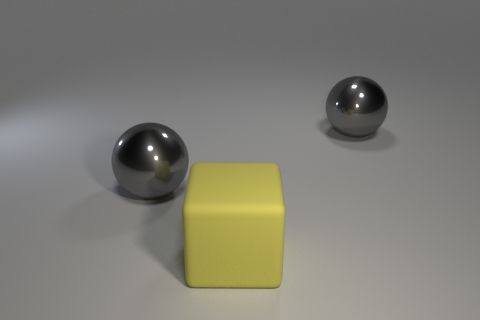Are there an equal number of rubber objects that are right of the large matte object and large green things?
Provide a succinct answer. Yes. The yellow matte cube is what size?
Ensure brevity in your answer.  Large. What number of blocks are left of the shiny thing that is to the right of the large matte block?
Offer a very short reply. 1. Are there any large metal balls that are on the left side of the large thing in front of the gray metallic thing that is left of the yellow cube?
Ensure brevity in your answer.  Yes. What number of balls are either large yellow objects or gray metal objects?
Provide a short and direct response. 2. What size is the gray sphere that is on the left side of the gray shiny thing behind the object that is on the left side of the matte cube?
Your answer should be very brief. Large. Do the yellow block and the gray metallic object that is to the left of the large yellow block have the same size?
Your response must be concise. Yes. How many other things are the same size as the yellow thing?
Your response must be concise. 2. How many things are gray metal balls to the right of the big matte cube or large spheres on the right side of the large yellow rubber cube?
Your answer should be compact. 1. There is a big gray shiny object on the right side of the large matte cube; what is its shape?
Offer a terse response. Sphere. 